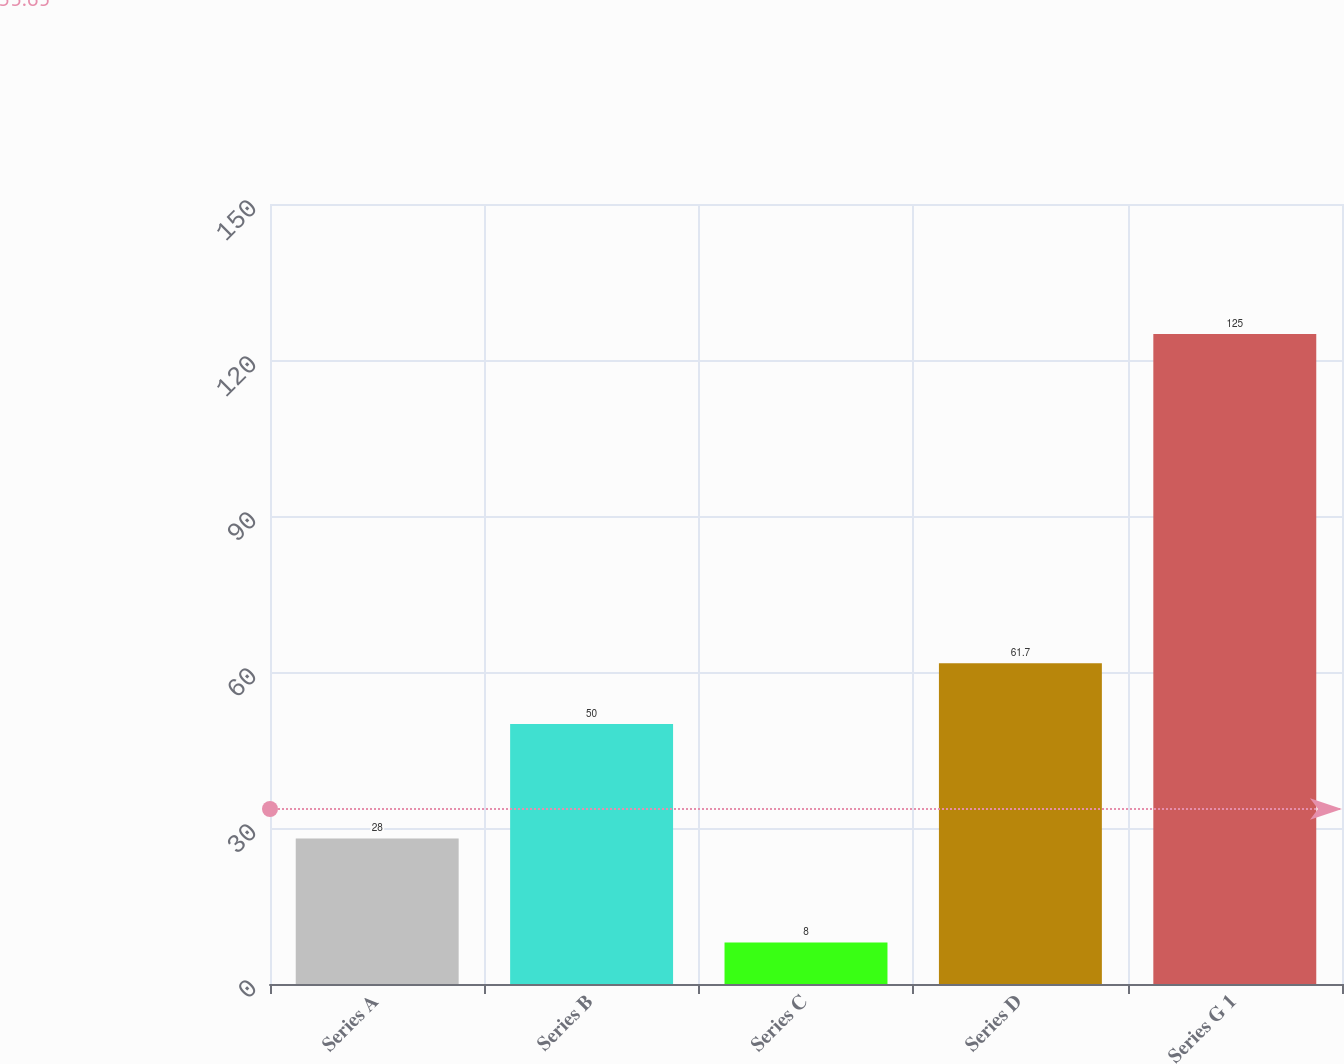Convert chart to OTSL. <chart><loc_0><loc_0><loc_500><loc_500><bar_chart><fcel>Series A<fcel>Series B<fcel>Series C<fcel>Series D<fcel>Series G 1<nl><fcel>28<fcel>50<fcel>8<fcel>61.7<fcel>125<nl></chart> 